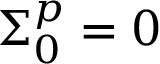Convert formula to latex. <formula><loc_0><loc_0><loc_500><loc_500>\Sigma _ { 0 } ^ { p } = 0</formula> 